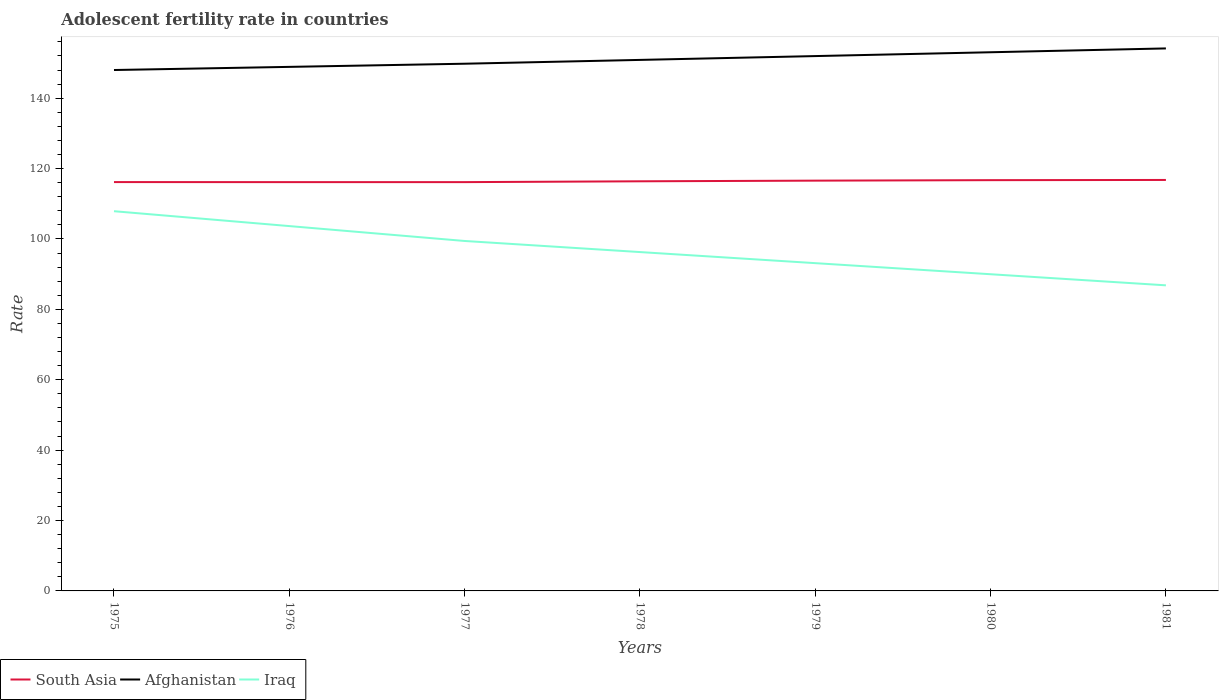How many different coloured lines are there?
Offer a terse response. 3. Across all years, what is the maximum adolescent fertility rate in Afghanistan?
Provide a short and direct response. 148. In which year was the adolescent fertility rate in Afghanistan maximum?
Your answer should be very brief. 1975. What is the total adolescent fertility rate in Iraq in the graph?
Offer a terse response. 3.15. What is the difference between the highest and the second highest adolescent fertility rate in Iraq?
Provide a succinct answer. 21.06. Is the adolescent fertility rate in Iraq strictly greater than the adolescent fertility rate in South Asia over the years?
Offer a terse response. Yes. How many lines are there?
Provide a succinct answer. 3. How many years are there in the graph?
Provide a short and direct response. 7. Are the values on the major ticks of Y-axis written in scientific E-notation?
Provide a succinct answer. No. Does the graph contain any zero values?
Offer a terse response. No. Does the graph contain grids?
Give a very brief answer. No. Where does the legend appear in the graph?
Ensure brevity in your answer.  Bottom left. What is the title of the graph?
Your answer should be very brief. Adolescent fertility rate in countries. Does "Libya" appear as one of the legend labels in the graph?
Offer a very short reply. No. What is the label or title of the Y-axis?
Offer a terse response. Rate. What is the Rate of South Asia in 1975?
Make the answer very short. 116.16. What is the Rate in Afghanistan in 1975?
Your response must be concise. 148. What is the Rate in Iraq in 1975?
Give a very brief answer. 107.89. What is the Rate in South Asia in 1976?
Give a very brief answer. 116.15. What is the Rate in Afghanistan in 1976?
Offer a very short reply. 148.9. What is the Rate of Iraq in 1976?
Your answer should be compact. 103.66. What is the Rate in South Asia in 1977?
Make the answer very short. 116.15. What is the Rate in Afghanistan in 1977?
Ensure brevity in your answer.  149.79. What is the Rate of Iraq in 1977?
Offer a very short reply. 99.43. What is the Rate of South Asia in 1978?
Make the answer very short. 116.39. What is the Rate of Afghanistan in 1978?
Your response must be concise. 150.88. What is the Rate of Iraq in 1978?
Ensure brevity in your answer.  96.28. What is the Rate in South Asia in 1979?
Offer a terse response. 116.57. What is the Rate of Afghanistan in 1979?
Your response must be concise. 151.97. What is the Rate of Iraq in 1979?
Your response must be concise. 93.13. What is the Rate of South Asia in 1980?
Offer a very short reply. 116.71. What is the Rate in Afghanistan in 1980?
Give a very brief answer. 153.05. What is the Rate in Iraq in 1980?
Offer a terse response. 89.98. What is the Rate in South Asia in 1981?
Your answer should be compact. 116.77. What is the Rate in Afghanistan in 1981?
Provide a succinct answer. 154.14. What is the Rate in Iraq in 1981?
Make the answer very short. 86.83. Across all years, what is the maximum Rate in South Asia?
Offer a terse response. 116.77. Across all years, what is the maximum Rate of Afghanistan?
Your answer should be very brief. 154.14. Across all years, what is the maximum Rate in Iraq?
Offer a very short reply. 107.89. Across all years, what is the minimum Rate of South Asia?
Make the answer very short. 116.15. Across all years, what is the minimum Rate of Afghanistan?
Your answer should be compact. 148. Across all years, what is the minimum Rate in Iraq?
Provide a succinct answer. 86.83. What is the total Rate in South Asia in the graph?
Give a very brief answer. 814.9. What is the total Rate of Afghanistan in the graph?
Keep it short and to the point. 1056.73. What is the total Rate in Iraq in the graph?
Your answer should be very brief. 677.2. What is the difference between the Rate in South Asia in 1975 and that in 1976?
Offer a very short reply. 0.01. What is the difference between the Rate of Afghanistan in 1975 and that in 1976?
Your answer should be very brief. -0.89. What is the difference between the Rate of Iraq in 1975 and that in 1976?
Ensure brevity in your answer.  4.23. What is the difference between the Rate in South Asia in 1975 and that in 1977?
Your answer should be compact. 0.01. What is the difference between the Rate in Afghanistan in 1975 and that in 1977?
Make the answer very short. -1.79. What is the difference between the Rate in Iraq in 1975 and that in 1977?
Provide a short and direct response. 8.46. What is the difference between the Rate in South Asia in 1975 and that in 1978?
Your answer should be compact. -0.22. What is the difference between the Rate of Afghanistan in 1975 and that in 1978?
Offer a terse response. -2.88. What is the difference between the Rate of Iraq in 1975 and that in 1978?
Ensure brevity in your answer.  11.61. What is the difference between the Rate in South Asia in 1975 and that in 1979?
Make the answer very short. -0.41. What is the difference between the Rate of Afghanistan in 1975 and that in 1979?
Offer a terse response. -3.96. What is the difference between the Rate of Iraq in 1975 and that in 1979?
Make the answer very short. 14.76. What is the difference between the Rate in South Asia in 1975 and that in 1980?
Provide a succinct answer. -0.55. What is the difference between the Rate in Afghanistan in 1975 and that in 1980?
Provide a succinct answer. -5.05. What is the difference between the Rate in Iraq in 1975 and that in 1980?
Your response must be concise. 17.91. What is the difference between the Rate in South Asia in 1975 and that in 1981?
Offer a terse response. -0.61. What is the difference between the Rate in Afghanistan in 1975 and that in 1981?
Make the answer very short. -6.14. What is the difference between the Rate in Iraq in 1975 and that in 1981?
Ensure brevity in your answer.  21.06. What is the difference between the Rate in South Asia in 1976 and that in 1977?
Ensure brevity in your answer.  0. What is the difference between the Rate of Afghanistan in 1976 and that in 1977?
Offer a terse response. -0.89. What is the difference between the Rate in Iraq in 1976 and that in 1977?
Give a very brief answer. 4.23. What is the difference between the Rate of South Asia in 1976 and that in 1978?
Ensure brevity in your answer.  -0.23. What is the difference between the Rate of Afghanistan in 1976 and that in 1978?
Give a very brief answer. -1.98. What is the difference between the Rate in Iraq in 1976 and that in 1978?
Keep it short and to the point. 7.38. What is the difference between the Rate of South Asia in 1976 and that in 1979?
Provide a short and direct response. -0.42. What is the difference between the Rate of Afghanistan in 1976 and that in 1979?
Keep it short and to the point. -3.07. What is the difference between the Rate in Iraq in 1976 and that in 1979?
Your answer should be compact. 10.53. What is the difference between the Rate in South Asia in 1976 and that in 1980?
Your answer should be very brief. -0.56. What is the difference between the Rate of Afghanistan in 1976 and that in 1980?
Give a very brief answer. -4.16. What is the difference between the Rate of Iraq in 1976 and that in 1980?
Give a very brief answer. 13.68. What is the difference between the Rate of South Asia in 1976 and that in 1981?
Offer a terse response. -0.62. What is the difference between the Rate in Afghanistan in 1976 and that in 1981?
Make the answer very short. -5.24. What is the difference between the Rate in Iraq in 1976 and that in 1981?
Offer a terse response. 16.83. What is the difference between the Rate in South Asia in 1977 and that in 1978?
Your answer should be very brief. -0.24. What is the difference between the Rate of Afghanistan in 1977 and that in 1978?
Offer a terse response. -1.09. What is the difference between the Rate of Iraq in 1977 and that in 1978?
Offer a terse response. 3.15. What is the difference between the Rate in South Asia in 1977 and that in 1979?
Ensure brevity in your answer.  -0.43. What is the difference between the Rate in Afghanistan in 1977 and that in 1979?
Ensure brevity in your answer.  -2.17. What is the difference between the Rate in Iraq in 1977 and that in 1979?
Ensure brevity in your answer.  6.3. What is the difference between the Rate of South Asia in 1977 and that in 1980?
Keep it short and to the point. -0.56. What is the difference between the Rate in Afghanistan in 1977 and that in 1980?
Your answer should be compact. -3.26. What is the difference between the Rate in Iraq in 1977 and that in 1980?
Your response must be concise. 9.45. What is the difference between the Rate in South Asia in 1977 and that in 1981?
Your answer should be compact. -0.62. What is the difference between the Rate of Afghanistan in 1977 and that in 1981?
Provide a succinct answer. -4.35. What is the difference between the Rate of Iraq in 1977 and that in 1981?
Offer a very short reply. 12.6. What is the difference between the Rate in South Asia in 1978 and that in 1979?
Your answer should be very brief. -0.19. What is the difference between the Rate of Afghanistan in 1978 and that in 1979?
Provide a succinct answer. -1.09. What is the difference between the Rate in Iraq in 1978 and that in 1979?
Your answer should be compact. 3.15. What is the difference between the Rate in South Asia in 1978 and that in 1980?
Ensure brevity in your answer.  -0.32. What is the difference between the Rate in Afghanistan in 1978 and that in 1980?
Give a very brief answer. -2.17. What is the difference between the Rate of Iraq in 1978 and that in 1980?
Ensure brevity in your answer.  6.3. What is the difference between the Rate in South Asia in 1978 and that in 1981?
Ensure brevity in your answer.  -0.38. What is the difference between the Rate in Afghanistan in 1978 and that in 1981?
Provide a short and direct response. -3.26. What is the difference between the Rate of Iraq in 1978 and that in 1981?
Provide a short and direct response. 9.45. What is the difference between the Rate of South Asia in 1979 and that in 1980?
Keep it short and to the point. -0.14. What is the difference between the Rate of Afghanistan in 1979 and that in 1980?
Provide a short and direct response. -1.09. What is the difference between the Rate of Iraq in 1979 and that in 1980?
Your answer should be very brief. 3.15. What is the difference between the Rate in South Asia in 1979 and that in 1981?
Make the answer very short. -0.19. What is the difference between the Rate in Afghanistan in 1979 and that in 1981?
Your response must be concise. -2.17. What is the difference between the Rate in Iraq in 1979 and that in 1981?
Your answer should be very brief. 6.3. What is the difference between the Rate in South Asia in 1980 and that in 1981?
Keep it short and to the point. -0.06. What is the difference between the Rate in Afghanistan in 1980 and that in 1981?
Provide a succinct answer. -1.09. What is the difference between the Rate of Iraq in 1980 and that in 1981?
Give a very brief answer. 3.15. What is the difference between the Rate in South Asia in 1975 and the Rate in Afghanistan in 1976?
Your answer should be compact. -32.73. What is the difference between the Rate of South Asia in 1975 and the Rate of Iraq in 1976?
Make the answer very short. 12.5. What is the difference between the Rate in Afghanistan in 1975 and the Rate in Iraq in 1976?
Ensure brevity in your answer.  44.34. What is the difference between the Rate of South Asia in 1975 and the Rate of Afghanistan in 1977?
Your response must be concise. -33.63. What is the difference between the Rate of South Asia in 1975 and the Rate of Iraq in 1977?
Offer a terse response. 16.73. What is the difference between the Rate of Afghanistan in 1975 and the Rate of Iraq in 1977?
Offer a terse response. 48.57. What is the difference between the Rate of South Asia in 1975 and the Rate of Afghanistan in 1978?
Provide a succinct answer. -34.72. What is the difference between the Rate in South Asia in 1975 and the Rate in Iraq in 1978?
Your answer should be very brief. 19.88. What is the difference between the Rate of Afghanistan in 1975 and the Rate of Iraq in 1978?
Offer a terse response. 51.72. What is the difference between the Rate in South Asia in 1975 and the Rate in Afghanistan in 1979?
Provide a succinct answer. -35.8. What is the difference between the Rate in South Asia in 1975 and the Rate in Iraq in 1979?
Your answer should be very brief. 23.03. What is the difference between the Rate of Afghanistan in 1975 and the Rate of Iraq in 1979?
Give a very brief answer. 54.87. What is the difference between the Rate in South Asia in 1975 and the Rate in Afghanistan in 1980?
Keep it short and to the point. -36.89. What is the difference between the Rate of South Asia in 1975 and the Rate of Iraq in 1980?
Your answer should be very brief. 26.18. What is the difference between the Rate in Afghanistan in 1975 and the Rate in Iraq in 1980?
Offer a very short reply. 58.02. What is the difference between the Rate of South Asia in 1975 and the Rate of Afghanistan in 1981?
Your answer should be compact. -37.98. What is the difference between the Rate of South Asia in 1975 and the Rate of Iraq in 1981?
Ensure brevity in your answer.  29.33. What is the difference between the Rate in Afghanistan in 1975 and the Rate in Iraq in 1981?
Provide a short and direct response. 61.17. What is the difference between the Rate in South Asia in 1976 and the Rate in Afghanistan in 1977?
Provide a succinct answer. -33.64. What is the difference between the Rate in South Asia in 1976 and the Rate in Iraq in 1977?
Make the answer very short. 16.72. What is the difference between the Rate in Afghanistan in 1976 and the Rate in Iraq in 1977?
Offer a terse response. 49.47. What is the difference between the Rate of South Asia in 1976 and the Rate of Afghanistan in 1978?
Make the answer very short. -34.73. What is the difference between the Rate in South Asia in 1976 and the Rate in Iraq in 1978?
Offer a very short reply. 19.87. What is the difference between the Rate in Afghanistan in 1976 and the Rate in Iraq in 1978?
Provide a succinct answer. 52.62. What is the difference between the Rate in South Asia in 1976 and the Rate in Afghanistan in 1979?
Provide a short and direct response. -35.81. What is the difference between the Rate of South Asia in 1976 and the Rate of Iraq in 1979?
Offer a terse response. 23.02. What is the difference between the Rate of Afghanistan in 1976 and the Rate of Iraq in 1979?
Provide a short and direct response. 55.77. What is the difference between the Rate of South Asia in 1976 and the Rate of Afghanistan in 1980?
Give a very brief answer. -36.9. What is the difference between the Rate of South Asia in 1976 and the Rate of Iraq in 1980?
Your response must be concise. 26.17. What is the difference between the Rate in Afghanistan in 1976 and the Rate in Iraq in 1980?
Your answer should be very brief. 58.92. What is the difference between the Rate in South Asia in 1976 and the Rate in Afghanistan in 1981?
Your response must be concise. -37.99. What is the difference between the Rate of South Asia in 1976 and the Rate of Iraq in 1981?
Offer a terse response. 29.32. What is the difference between the Rate in Afghanistan in 1976 and the Rate in Iraq in 1981?
Ensure brevity in your answer.  62.07. What is the difference between the Rate of South Asia in 1977 and the Rate of Afghanistan in 1978?
Provide a succinct answer. -34.73. What is the difference between the Rate in South Asia in 1977 and the Rate in Iraq in 1978?
Make the answer very short. 19.87. What is the difference between the Rate in Afghanistan in 1977 and the Rate in Iraq in 1978?
Keep it short and to the point. 53.51. What is the difference between the Rate of South Asia in 1977 and the Rate of Afghanistan in 1979?
Provide a succinct answer. -35.82. What is the difference between the Rate in South Asia in 1977 and the Rate in Iraq in 1979?
Your answer should be compact. 23.02. What is the difference between the Rate of Afghanistan in 1977 and the Rate of Iraq in 1979?
Provide a succinct answer. 56.66. What is the difference between the Rate in South Asia in 1977 and the Rate in Afghanistan in 1980?
Ensure brevity in your answer.  -36.9. What is the difference between the Rate in South Asia in 1977 and the Rate in Iraq in 1980?
Give a very brief answer. 26.17. What is the difference between the Rate in Afghanistan in 1977 and the Rate in Iraq in 1980?
Offer a terse response. 59.81. What is the difference between the Rate in South Asia in 1977 and the Rate in Afghanistan in 1981?
Ensure brevity in your answer.  -37.99. What is the difference between the Rate in South Asia in 1977 and the Rate in Iraq in 1981?
Offer a very short reply. 29.32. What is the difference between the Rate in Afghanistan in 1977 and the Rate in Iraq in 1981?
Your response must be concise. 62.96. What is the difference between the Rate of South Asia in 1978 and the Rate of Afghanistan in 1979?
Make the answer very short. -35.58. What is the difference between the Rate of South Asia in 1978 and the Rate of Iraq in 1979?
Your answer should be compact. 23.26. What is the difference between the Rate of Afghanistan in 1978 and the Rate of Iraq in 1979?
Offer a very short reply. 57.75. What is the difference between the Rate in South Asia in 1978 and the Rate in Afghanistan in 1980?
Keep it short and to the point. -36.67. What is the difference between the Rate of South Asia in 1978 and the Rate of Iraq in 1980?
Your answer should be very brief. 26.41. What is the difference between the Rate in Afghanistan in 1978 and the Rate in Iraq in 1980?
Offer a very short reply. 60.9. What is the difference between the Rate in South Asia in 1978 and the Rate in Afghanistan in 1981?
Ensure brevity in your answer.  -37.75. What is the difference between the Rate of South Asia in 1978 and the Rate of Iraq in 1981?
Keep it short and to the point. 29.56. What is the difference between the Rate in Afghanistan in 1978 and the Rate in Iraq in 1981?
Ensure brevity in your answer.  64.05. What is the difference between the Rate of South Asia in 1979 and the Rate of Afghanistan in 1980?
Provide a short and direct response. -36.48. What is the difference between the Rate of South Asia in 1979 and the Rate of Iraq in 1980?
Ensure brevity in your answer.  26.59. What is the difference between the Rate in Afghanistan in 1979 and the Rate in Iraq in 1980?
Your answer should be very brief. 61.99. What is the difference between the Rate of South Asia in 1979 and the Rate of Afghanistan in 1981?
Provide a short and direct response. -37.57. What is the difference between the Rate of South Asia in 1979 and the Rate of Iraq in 1981?
Provide a succinct answer. 29.74. What is the difference between the Rate of Afghanistan in 1979 and the Rate of Iraq in 1981?
Ensure brevity in your answer.  65.14. What is the difference between the Rate in South Asia in 1980 and the Rate in Afghanistan in 1981?
Offer a very short reply. -37.43. What is the difference between the Rate of South Asia in 1980 and the Rate of Iraq in 1981?
Offer a terse response. 29.88. What is the difference between the Rate in Afghanistan in 1980 and the Rate in Iraq in 1981?
Make the answer very short. 66.22. What is the average Rate of South Asia per year?
Offer a terse response. 116.41. What is the average Rate in Afghanistan per year?
Your answer should be very brief. 150.96. What is the average Rate of Iraq per year?
Ensure brevity in your answer.  96.74. In the year 1975, what is the difference between the Rate in South Asia and Rate in Afghanistan?
Give a very brief answer. -31.84. In the year 1975, what is the difference between the Rate in South Asia and Rate in Iraq?
Offer a terse response. 8.27. In the year 1975, what is the difference between the Rate in Afghanistan and Rate in Iraq?
Your answer should be very brief. 40.11. In the year 1976, what is the difference between the Rate of South Asia and Rate of Afghanistan?
Ensure brevity in your answer.  -32.75. In the year 1976, what is the difference between the Rate in South Asia and Rate in Iraq?
Give a very brief answer. 12.49. In the year 1976, what is the difference between the Rate of Afghanistan and Rate of Iraq?
Your response must be concise. 45.24. In the year 1977, what is the difference between the Rate in South Asia and Rate in Afghanistan?
Offer a very short reply. -33.64. In the year 1977, what is the difference between the Rate in South Asia and Rate in Iraq?
Make the answer very short. 16.72. In the year 1977, what is the difference between the Rate in Afghanistan and Rate in Iraq?
Your answer should be very brief. 50.36. In the year 1978, what is the difference between the Rate of South Asia and Rate of Afghanistan?
Provide a succinct answer. -34.49. In the year 1978, what is the difference between the Rate in South Asia and Rate in Iraq?
Provide a succinct answer. 20.11. In the year 1978, what is the difference between the Rate in Afghanistan and Rate in Iraq?
Give a very brief answer. 54.6. In the year 1979, what is the difference between the Rate of South Asia and Rate of Afghanistan?
Give a very brief answer. -35.39. In the year 1979, what is the difference between the Rate of South Asia and Rate of Iraq?
Keep it short and to the point. 23.44. In the year 1979, what is the difference between the Rate in Afghanistan and Rate in Iraq?
Offer a terse response. 58.84. In the year 1980, what is the difference between the Rate of South Asia and Rate of Afghanistan?
Offer a very short reply. -36.34. In the year 1980, what is the difference between the Rate in South Asia and Rate in Iraq?
Offer a very short reply. 26.73. In the year 1980, what is the difference between the Rate of Afghanistan and Rate of Iraq?
Ensure brevity in your answer.  63.07. In the year 1981, what is the difference between the Rate in South Asia and Rate in Afghanistan?
Keep it short and to the point. -37.37. In the year 1981, what is the difference between the Rate in South Asia and Rate in Iraq?
Provide a short and direct response. 29.94. In the year 1981, what is the difference between the Rate in Afghanistan and Rate in Iraq?
Keep it short and to the point. 67.31. What is the ratio of the Rate of South Asia in 1975 to that in 1976?
Give a very brief answer. 1. What is the ratio of the Rate in Afghanistan in 1975 to that in 1976?
Offer a very short reply. 0.99. What is the ratio of the Rate of Iraq in 1975 to that in 1976?
Offer a terse response. 1.04. What is the ratio of the Rate in Iraq in 1975 to that in 1977?
Provide a succinct answer. 1.09. What is the ratio of the Rate of Afghanistan in 1975 to that in 1978?
Your response must be concise. 0.98. What is the ratio of the Rate in Iraq in 1975 to that in 1978?
Offer a very short reply. 1.12. What is the ratio of the Rate in Afghanistan in 1975 to that in 1979?
Ensure brevity in your answer.  0.97. What is the ratio of the Rate of Iraq in 1975 to that in 1979?
Offer a very short reply. 1.16. What is the ratio of the Rate in South Asia in 1975 to that in 1980?
Make the answer very short. 1. What is the ratio of the Rate in Afghanistan in 1975 to that in 1980?
Provide a succinct answer. 0.97. What is the ratio of the Rate of Iraq in 1975 to that in 1980?
Give a very brief answer. 1.2. What is the ratio of the Rate of Afghanistan in 1975 to that in 1981?
Offer a very short reply. 0.96. What is the ratio of the Rate in Iraq in 1975 to that in 1981?
Keep it short and to the point. 1.24. What is the ratio of the Rate in Afghanistan in 1976 to that in 1977?
Offer a very short reply. 0.99. What is the ratio of the Rate in Iraq in 1976 to that in 1977?
Give a very brief answer. 1.04. What is the ratio of the Rate of South Asia in 1976 to that in 1978?
Your response must be concise. 1. What is the ratio of the Rate of Afghanistan in 1976 to that in 1978?
Keep it short and to the point. 0.99. What is the ratio of the Rate in Iraq in 1976 to that in 1978?
Your response must be concise. 1.08. What is the ratio of the Rate of Afghanistan in 1976 to that in 1979?
Provide a succinct answer. 0.98. What is the ratio of the Rate of Iraq in 1976 to that in 1979?
Provide a short and direct response. 1.11. What is the ratio of the Rate in South Asia in 1976 to that in 1980?
Make the answer very short. 1. What is the ratio of the Rate in Afghanistan in 1976 to that in 1980?
Offer a terse response. 0.97. What is the ratio of the Rate in Iraq in 1976 to that in 1980?
Provide a short and direct response. 1.15. What is the ratio of the Rate of South Asia in 1976 to that in 1981?
Ensure brevity in your answer.  0.99. What is the ratio of the Rate in Iraq in 1976 to that in 1981?
Your answer should be very brief. 1.19. What is the ratio of the Rate in Iraq in 1977 to that in 1978?
Your response must be concise. 1.03. What is the ratio of the Rate of South Asia in 1977 to that in 1979?
Provide a short and direct response. 1. What is the ratio of the Rate of Afghanistan in 1977 to that in 1979?
Keep it short and to the point. 0.99. What is the ratio of the Rate in Iraq in 1977 to that in 1979?
Provide a short and direct response. 1.07. What is the ratio of the Rate of Afghanistan in 1977 to that in 1980?
Your answer should be very brief. 0.98. What is the ratio of the Rate of Iraq in 1977 to that in 1980?
Keep it short and to the point. 1.1. What is the ratio of the Rate in Afghanistan in 1977 to that in 1981?
Make the answer very short. 0.97. What is the ratio of the Rate in Iraq in 1977 to that in 1981?
Your response must be concise. 1.15. What is the ratio of the Rate of Afghanistan in 1978 to that in 1979?
Give a very brief answer. 0.99. What is the ratio of the Rate of Iraq in 1978 to that in 1979?
Offer a terse response. 1.03. What is the ratio of the Rate of South Asia in 1978 to that in 1980?
Offer a terse response. 1. What is the ratio of the Rate of Afghanistan in 1978 to that in 1980?
Give a very brief answer. 0.99. What is the ratio of the Rate of Iraq in 1978 to that in 1980?
Make the answer very short. 1.07. What is the ratio of the Rate of Afghanistan in 1978 to that in 1981?
Ensure brevity in your answer.  0.98. What is the ratio of the Rate in Iraq in 1978 to that in 1981?
Provide a short and direct response. 1.11. What is the ratio of the Rate of Afghanistan in 1979 to that in 1980?
Offer a terse response. 0.99. What is the ratio of the Rate of Iraq in 1979 to that in 1980?
Give a very brief answer. 1.03. What is the ratio of the Rate of Afghanistan in 1979 to that in 1981?
Give a very brief answer. 0.99. What is the ratio of the Rate of Iraq in 1979 to that in 1981?
Make the answer very short. 1.07. What is the ratio of the Rate in Afghanistan in 1980 to that in 1981?
Offer a very short reply. 0.99. What is the ratio of the Rate in Iraq in 1980 to that in 1981?
Keep it short and to the point. 1.04. What is the difference between the highest and the second highest Rate in South Asia?
Offer a very short reply. 0.06. What is the difference between the highest and the second highest Rate of Afghanistan?
Offer a terse response. 1.09. What is the difference between the highest and the second highest Rate of Iraq?
Provide a succinct answer. 4.23. What is the difference between the highest and the lowest Rate of South Asia?
Make the answer very short. 0.62. What is the difference between the highest and the lowest Rate in Afghanistan?
Provide a short and direct response. 6.14. What is the difference between the highest and the lowest Rate of Iraq?
Provide a succinct answer. 21.06. 